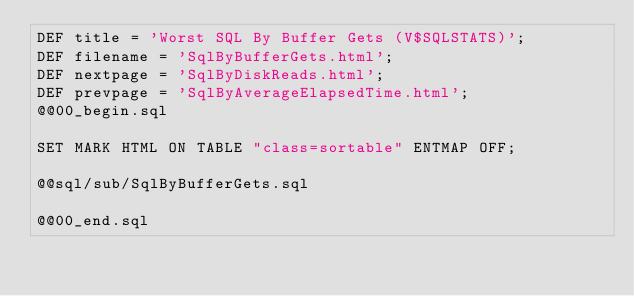<code> <loc_0><loc_0><loc_500><loc_500><_SQL_>DEF title = 'Worst SQL By Buffer Gets (V$SQLSTATS)';
DEF filename = 'SqlByBufferGets.html';
DEF nextpage = 'SqlByDiskReads.html';
DEF prevpage = 'SqlByAverageElapsedTime.html';
@@00_begin.sql

SET MARK HTML ON TABLE "class=sortable" ENTMAP OFF;

@@sql/sub/SqlByBufferGets.sql

@@00_end.sql
</code> 